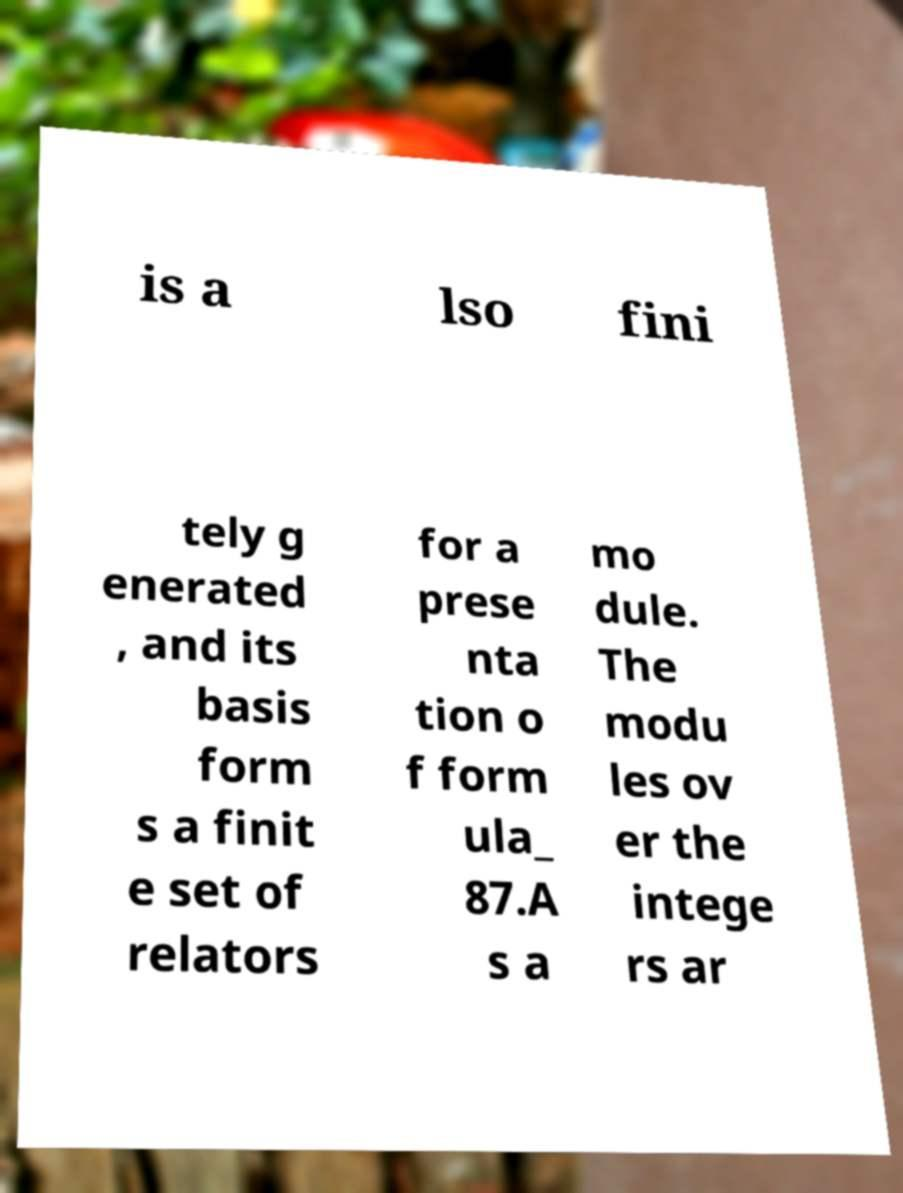There's text embedded in this image that I need extracted. Can you transcribe it verbatim? is a lso fini tely g enerated , and its basis form s a finit e set of relators for a prese nta tion o f form ula_ 87.A s a mo dule. The modu les ov er the intege rs ar 